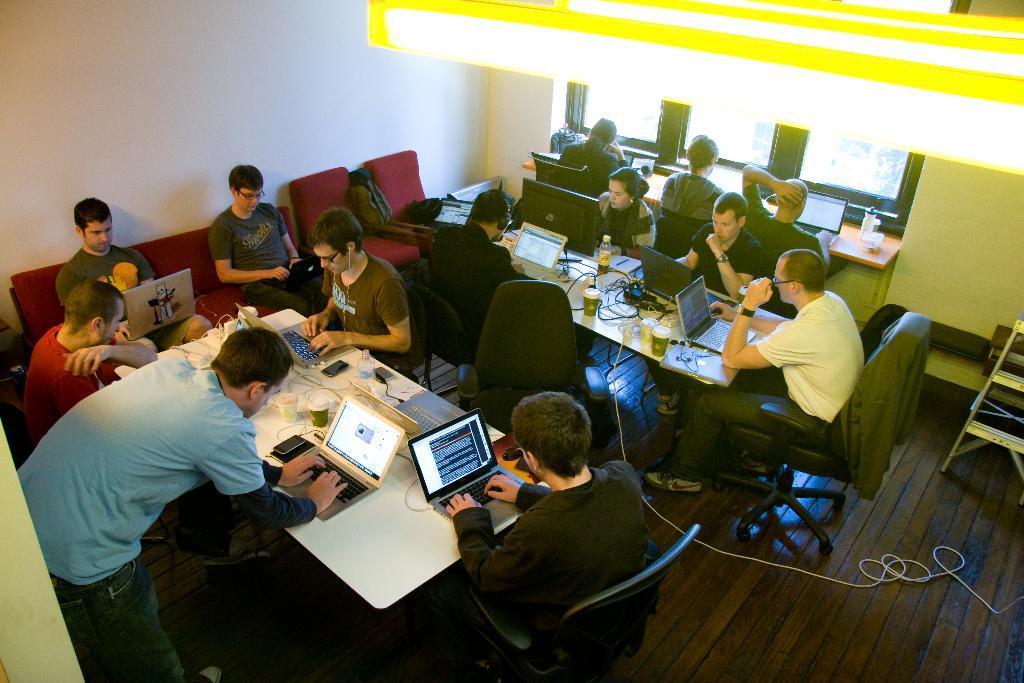Describe this image in one or two sentences. This Image is clicked in a room. There are lights on the top. There are so many chairs and tables people are sitting on chairs. There are wires in the bottom ,there is a ladder on the right side. On the table there are coffee glasses ,Water bottles, laptops, wires, mobile, phones, books. There are windows on the right side. 